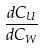Convert formula to latex. <formula><loc_0><loc_0><loc_500><loc_500>\frac { d C _ { U } } { d C _ { W } }</formula> 